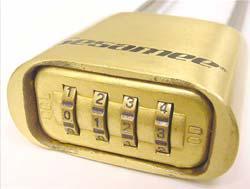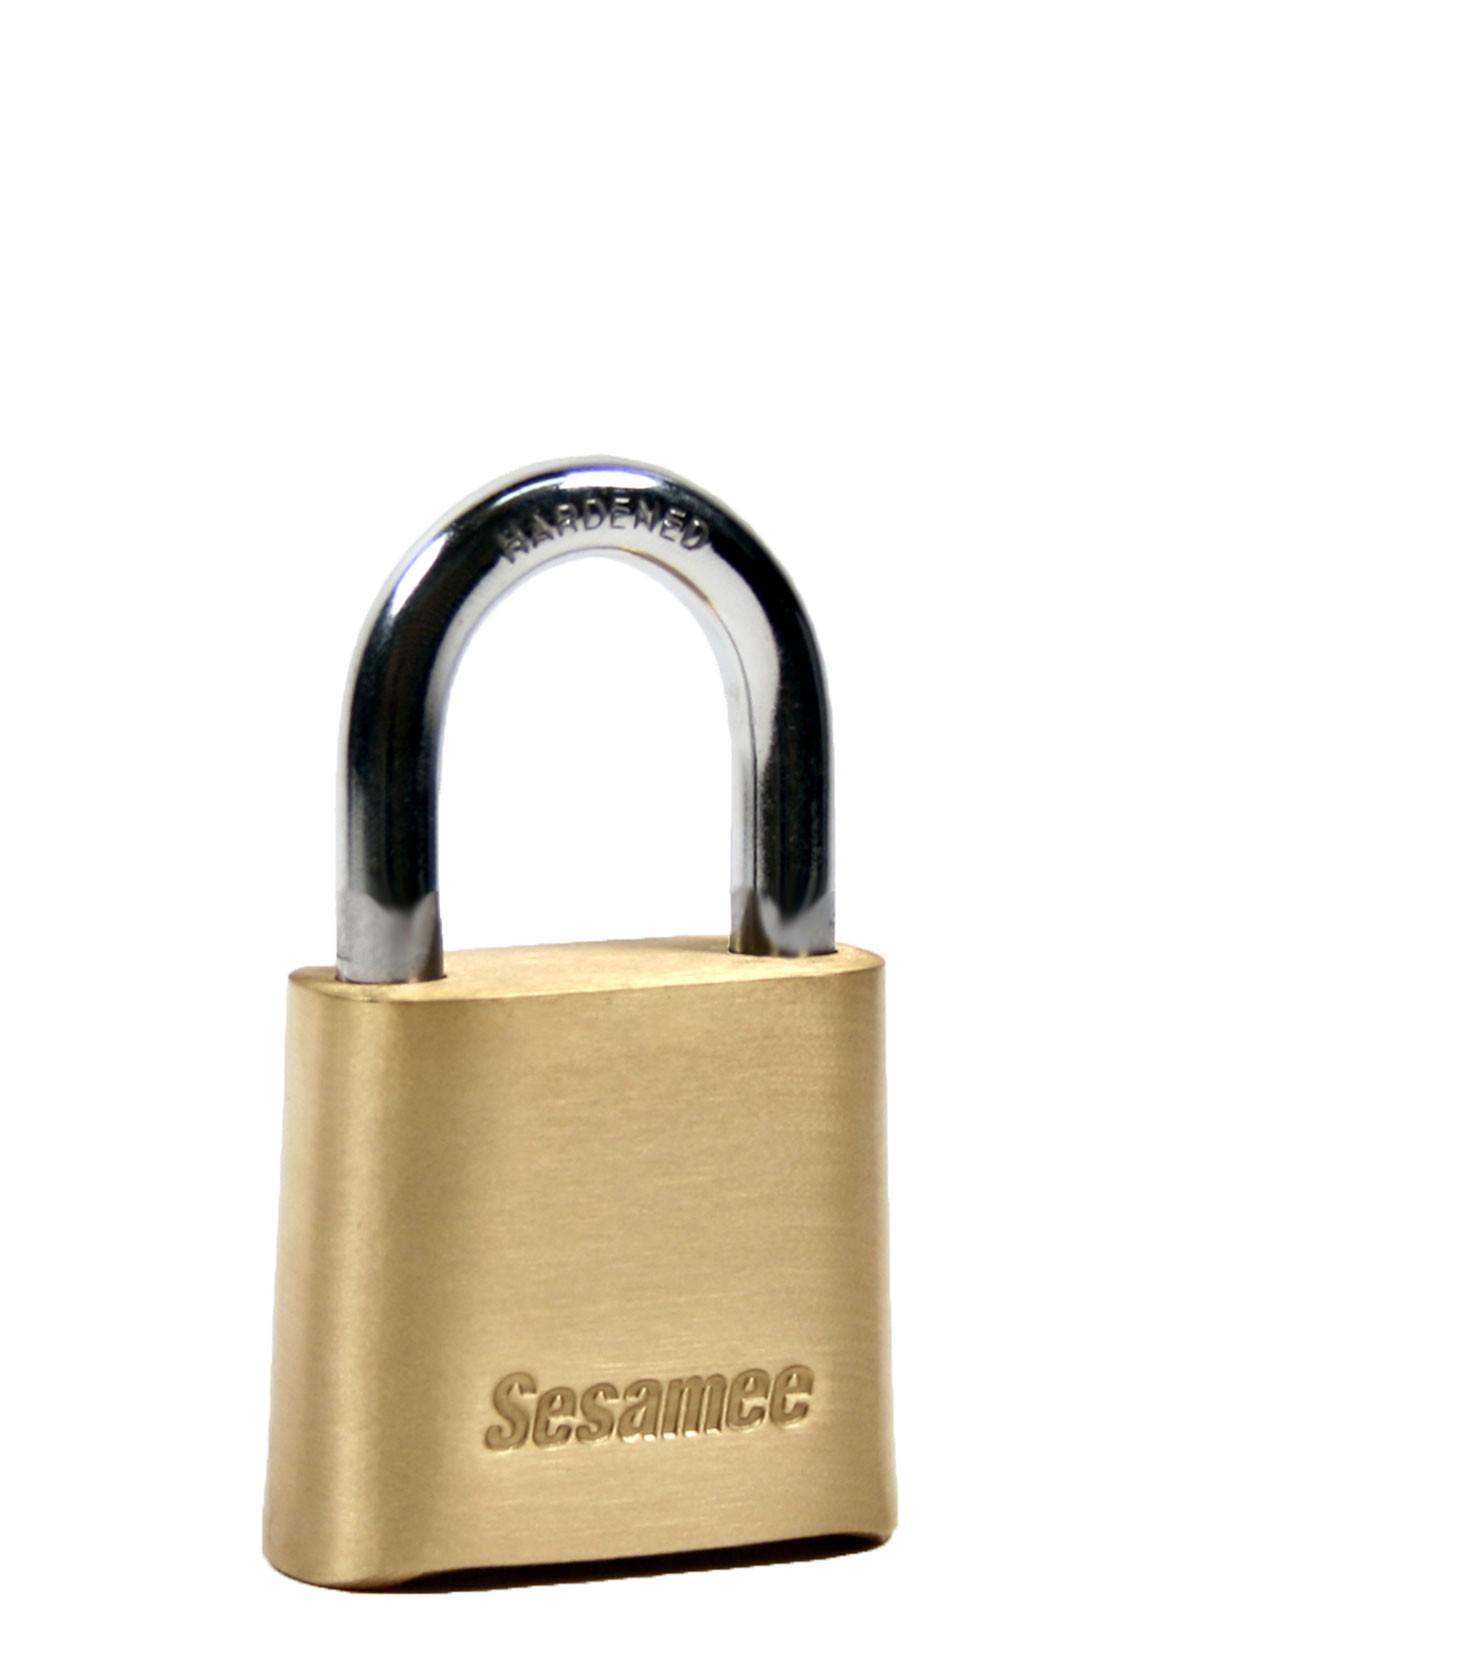The first image is the image on the left, the second image is the image on the right. For the images shown, is this caption "Two locks are both roughly square shaped, but the metal loop of one lock is much longer than the loop of the other lock." true? Answer yes or no. No. The first image is the image on the left, the second image is the image on the right. Assess this claim about the two images: "The body of both locks is made of gold colored metal.". Correct or not? Answer yes or no. Yes. 